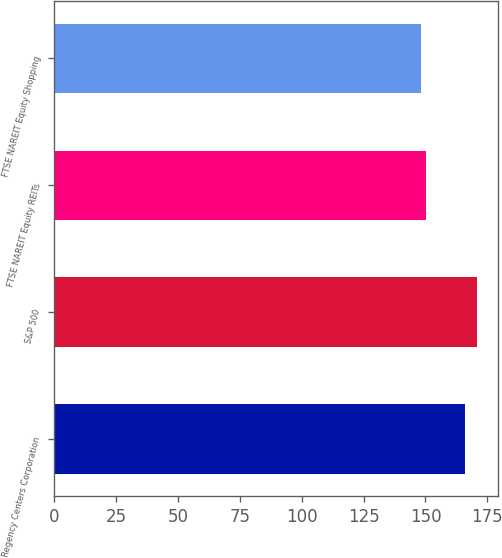Convert chart to OTSL. <chart><loc_0><loc_0><loc_500><loc_500><bar_chart><fcel>Regency Centers Corporation<fcel>S&P 500<fcel>FTSE NAREIT Equity REITs<fcel>FTSE NAREIT Equity Shopping<nl><fcel>166<fcel>170.84<fcel>150.41<fcel>148.14<nl></chart> 